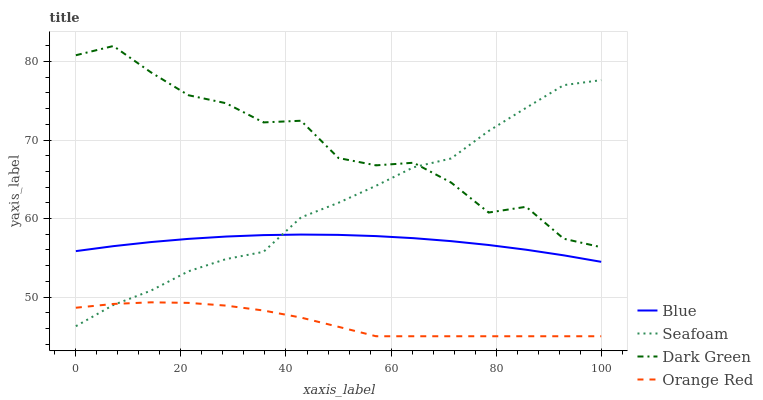Does Orange Red have the minimum area under the curve?
Answer yes or no. Yes. Does Dark Green have the maximum area under the curve?
Answer yes or no. Yes. Does Seafoam have the minimum area under the curve?
Answer yes or no. No. Does Seafoam have the maximum area under the curve?
Answer yes or no. No. Is Blue the smoothest?
Answer yes or no. Yes. Is Dark Green the roughest?
Answer yes or no. Yes. Is Seafoam the smoothest?
Answer yes or no. No. Is Seafoam the roughest?
Answer yes or no. No. Does Orange Red have the lowest value?
Answer yes or no. Yes. Does Seafoam have the lowest value?
Answer yes or no. No. Does Dark Green have the highest value?
Answer yes or no. Yes. Does Seafoam have the highest value?
Answer yes or no. No. Is Blue less than Dark Green?
Answer yes or no. Yes. Is Dark Green greater than Orange Red?
Answer yes or no. Yes. Does Blue intersect Seafoam?
Answer yes or no. Yes. Is Blue less than Seafoam?
Answer yes or no. No. Is Blue greater than Seafoam?
Answer yes or no. No. Does Blue intersect Dark Green?
Answer yes or no. No. 